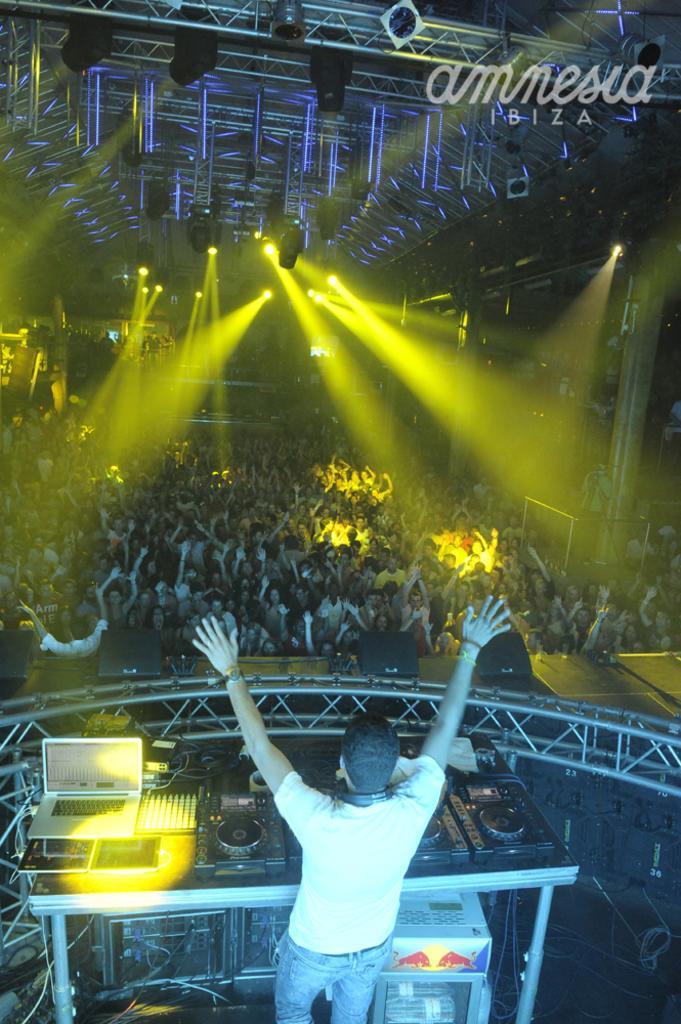Describe this image in one or two sentences. In this image we can see this person is standing near the table where we can see the laptop and few electronic devices are kept. Here we can see these people are standing and we can see show lights in the ceiling. Here we can see the watermark at the top right side of the image. 